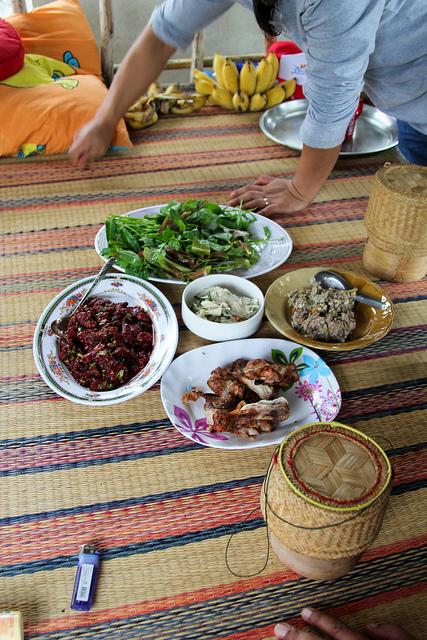What is closest to the person? Please explain your reasoning. banana. The banana is closest to the person's hand. 